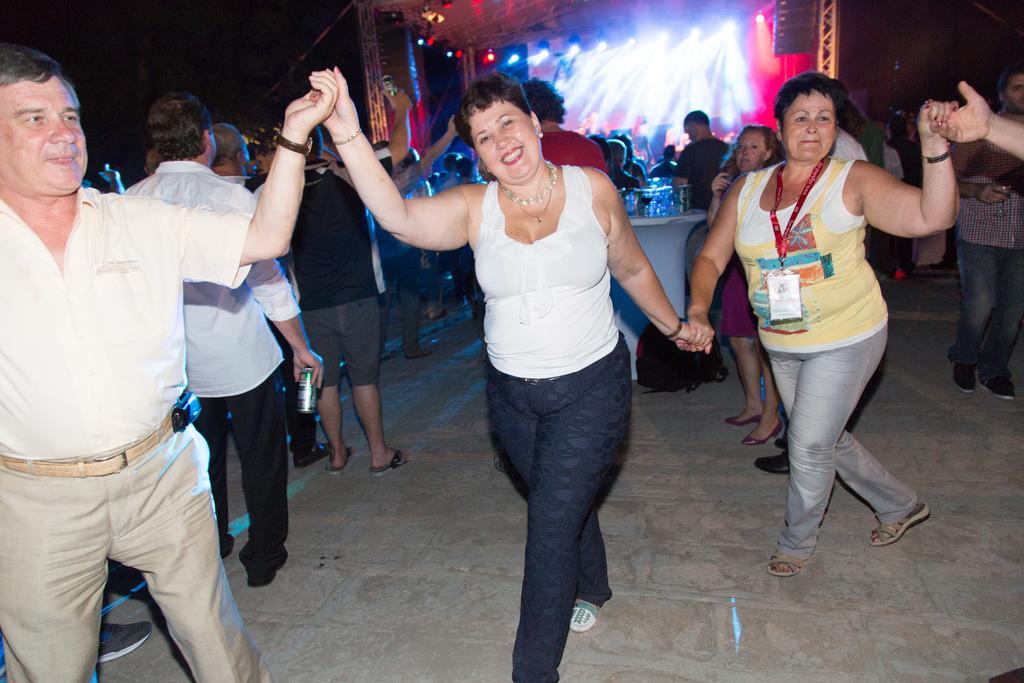Please provide a concise description of this image. In this image, we can see a group of people walking. In the background, we can also see a group of people are standing. In the background, we can see a table, on the table, we can see some glasses and a group of people, a few lights and some metal instrument. 